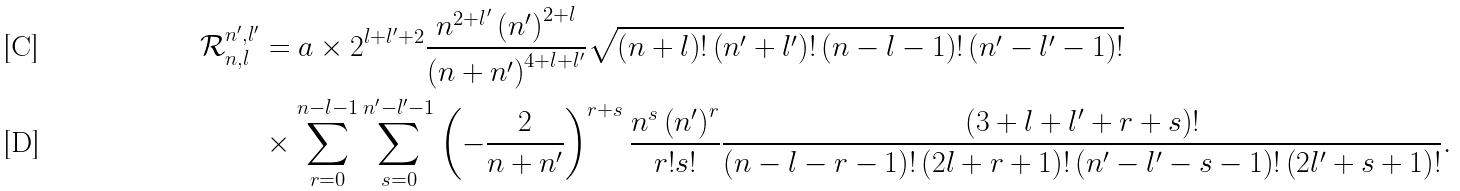Convert formula to latex. <formula><loc_0><loc_0><loc_500><loc_500>\mathcal { R } _ { n , l } ^ { n ^ { \prime } , l ^ { \prime } } & = a \times 2 ^ { l + l ^ { \prime } + 2 } \frac { n ^ { 2 + l ^ { \prime } } \left ( n ^ { \prime } \right ) ^ { 2 + l } } { \left ( n + n ^ { \prime } \right ) ^ { 4 + l + l ^ { \prime } } } \sqrt { \left ( n + l \right ) ! \left ( n ^ { \prime } + l ^ { \prime } \right ) ! \left ( n - l - 1 \right ) ! \left ( n ^ { \prime } - l ^ { \prime } - 1 \right ) ! } \\ & \times \sum _ { r = 0 } ^ { n - l - 1 } \sum _ { s = 0 } ^ { n ^ { \prime } - l ^ { \prime } - 1 } \left ( - \frac { 2 } { n + n ^ { \prime } } \right ) ^ { r + s } \frac { n ^ { s } \left ( n ^ { \prime } \right ) ^ { r } } { r ! s ! } \frac { \left ( 3 + l + l ^ { \prime } + r + s \right ) ! } { \left ( n - l - r - 1 \right ) ! \left ( 2 l + r + 1 \right ) ! \left ( n ^ { \prime } - l ^ { \prime } - s - 1 \right ) ! \left ( 2 l ^ { \prime } + s + 1 \right ) ! } .</formula> 